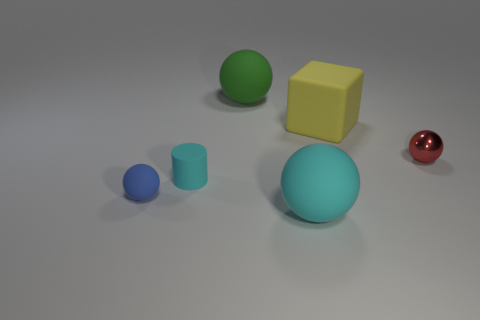Subtract all green cylinders. Subtract all brown spheres. How many cylinders are left? 1 Add 1 large objects. How many objects exist? 7 Subtract all spheres. How many objects are left? 2 Subtract 1 cyan spheres. How many objects are left? 5 Subtract all green matte things. Subtract all cyan matte things. How many objects are left? 3 Add 1 green matte things. How many green matte things are left? 2 Add 3 big purple metallic objects. How many big purple metallic objects exist? 3 